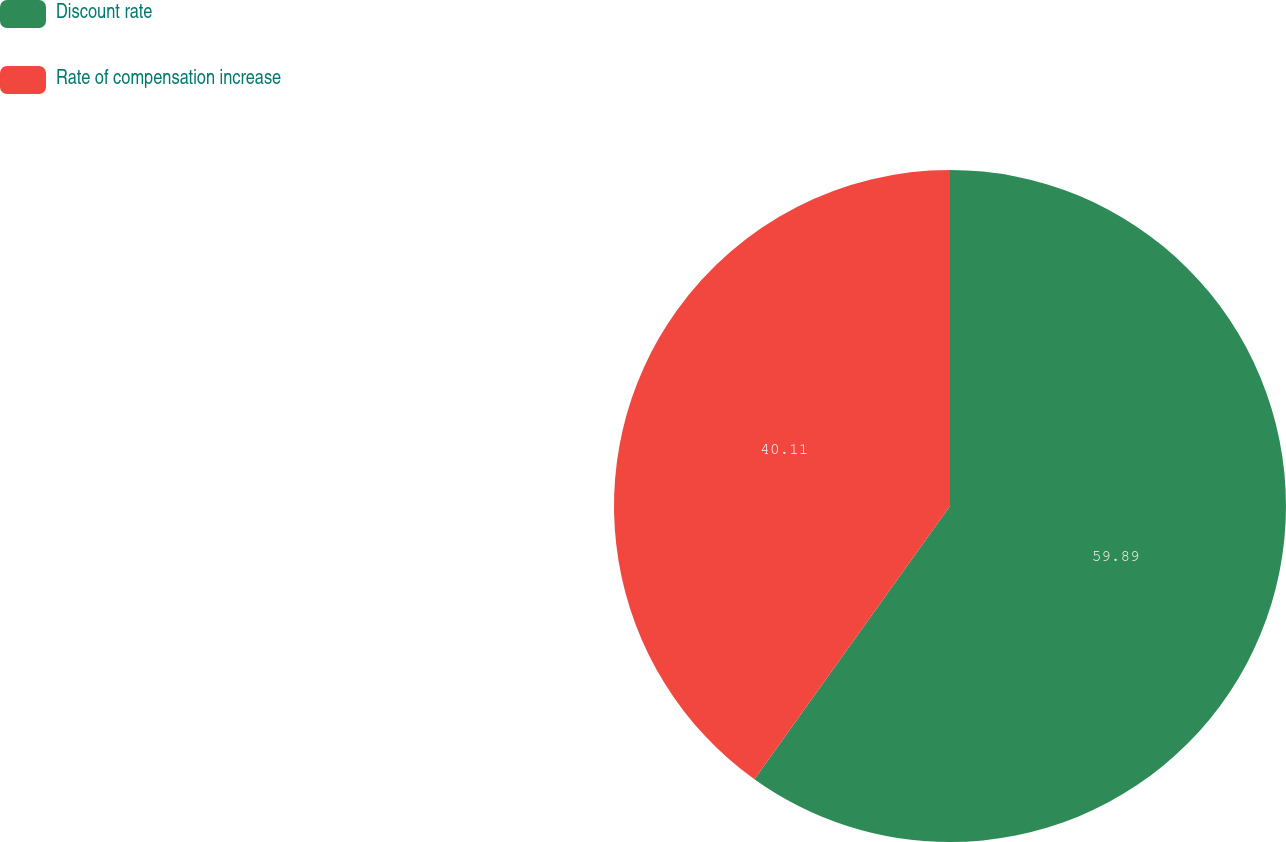<chart> <loc_0><loc_0><loc_500><loc_500><pie_chart><fcel>Discount rate<fcel>Rate of compensation increase<nl><fcel>59.89%<fcel>40.11%<nl></chart> 